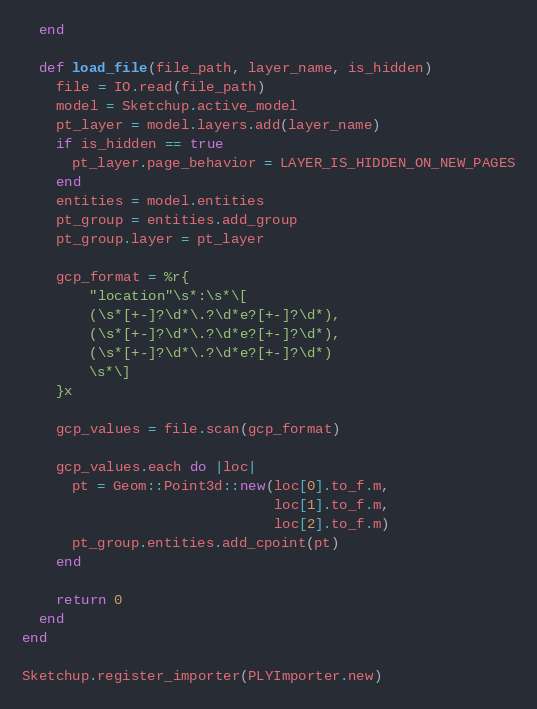Convert code to text. <code><loc_0><loc_0><loc_500><loc_500><_Ruby_>  end
    
  def load_file(file_path, layer_name, is_hidden)
    file = IO.read(file_path)
    model = Sketchup.active_model
    pt_layer = model.layers.add(layer_name)
    if is_hidden == true
      pt_layer.page_behavior = LAYER_IS_HIDDEN_ON_NEW_PAGES
    end
    entities = model.entities
    pt_group = entities.add_group
    pt_group.layer = pt_layer

    gcp_format = %r{
        "location"\s*:\s*\[
        (\s*[+-]?\d*\.?\d*e?[+-]?\d*),
        (\s*[+-]?\d*\.?\d*e?[+-]?\d*),
        (\s*[+-]?\d*\.?\d*e?[+-]?\d*)
        \s*\]
    }x

    gcp_values = file.scan(gcp_format)

    gcp_values.each do |loc|
      pt = Geom::Point3d::new(loc[0].to_f.m,
                              loc[1].to_f.m,
                              loc[2].to_f.m)
      pt_group.entities.add_cpoint(pt)
    end

    return 0
  end
end

Sketchup.register_importer(PLYImporter.new)
</code> 